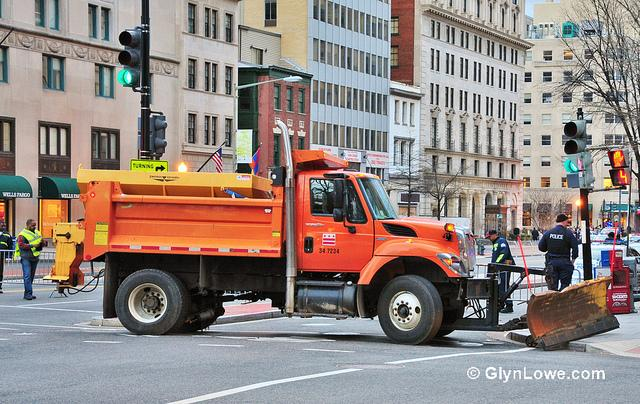Why is the man wearing a yellow vest? safety 